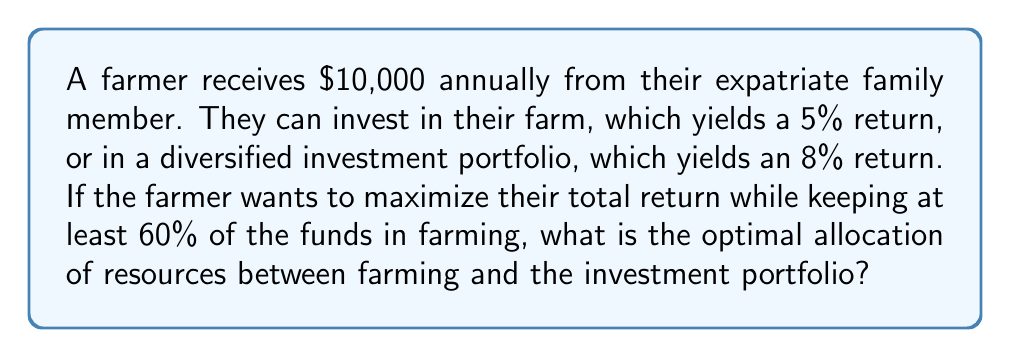Provide a solution to this math problem. Let's approach this step-by-step:

1) Let $x$ be the amount invested in farming, and $(10000 - x)$ be the amount invested in the portfolio.

2) The total return function is:
   $$R(x) = 0.05x + 0.08(10000 - x)$$

3) Simplify:
   $$R(x) = 0.05x + 800 - 0.08x = 800 - 0.03x$$

4) We want to maximize $R(x)$, but we have a constraint:
   $$x \geq 6000$$ (60% of $10,000)

5) Since $R(x)$ is a decreasing function of $x$, the maximum value will occur at the smallest allowed value of $x$, which is $6000.

6) Therefore, the optimal allocation is:
   Farming: $6000
   Portfolio: $4000

7) To verify, let's calculate the returns:
   Farming return: $0.05 * 6000 = $300
   Portfolio return: $0.08 * 4000 = $320
   Total return: $300 + $320 = $620
Answer: $6000 in farming, $4000 in portfolio 